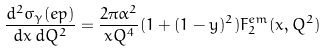<formula> <loc_0><loc_0><loc_500><loc_500>\frac { d ^ { 2 } \sigma _ { \gamma } ( e p ) } { d x \, d Q ^ { 2 } } = \frac { 2 \pi \alpha ^ { 2 } } { x Q ^ { 4 } } ( 1 + ( 1 - y ) ^ { 2 } ) F _ { 2 } ^ { e m } ( x , Q ^ { 2 } )</formula> 